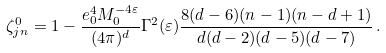<formula> <loc_0><loc_0><loc_500><loc_500>\zeta _ { j n } ^ { 0 } = 1 - \frac { e _ { 0 } ^ { 4 } M _ { 0 } ^ { - 4 \varepsilon } } { ( 4 \pi ) ^ { d } } \Gamma ^ { 2 } ( \varepsilon ) \frac { 8 ( d - 6 ) ( n - 1 ) ( n - d + 1 ) } { d ( d - 2 ) ( d - 5 ) ( d - 7 ) } \, .</formula> 